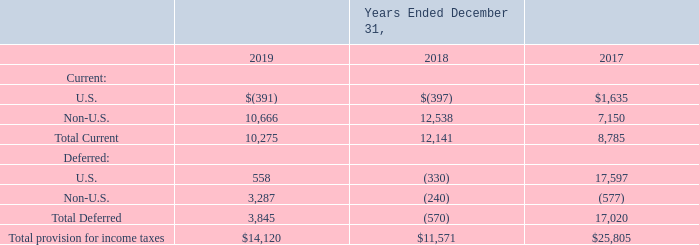NOTES TO CONSOLIDATED FINANCIAL STATEMENTS (in thousands, except for share and per share data)
NOTE 18 — Income Taxes
Significant components of income tax provision/(benefit) are as follows:
Which years does the table provide information for Significant components of income tax provision/(benefit)? 2019, 2018, 2017. What was the current income tax provision  for U.S. in 2018?
Answer scale should be: thousand. (397). What was the current income tax provision for Non-U.S. in 2017?
Answer scale should be: thousand. 7,150. How many years did the total deferred amount of income tax provision exceed $1,000 thousand? 2019##2017
Answer: 2. What was the change in the total current income tax provision  between 2017 and 2018?
Answer scale should be: thousand. 12,141-8,785
Answer: 3356. What was the percentage change in the Total provision for income taxes between 2018 and 2019?
Answer scale should be: percent. (14,120-11,571)/11,571
Answer: 22.03. 